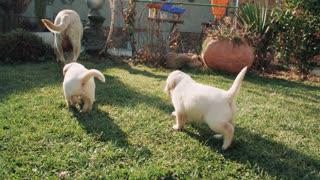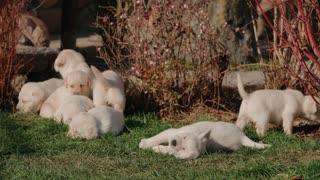The first image is the image on the left, the second image is the image on the right. Analyze the images presented: Is the assertion "In one of the images there are exactly two golden labs interacting with each other." valid? Answer yes or no. No. The first image is the image on the left, the second image is the image on the right. For the images displayed, is the sentence "One image features exactly two dogs relaxing on the grass." factually correct? Answer yes or no. No. 